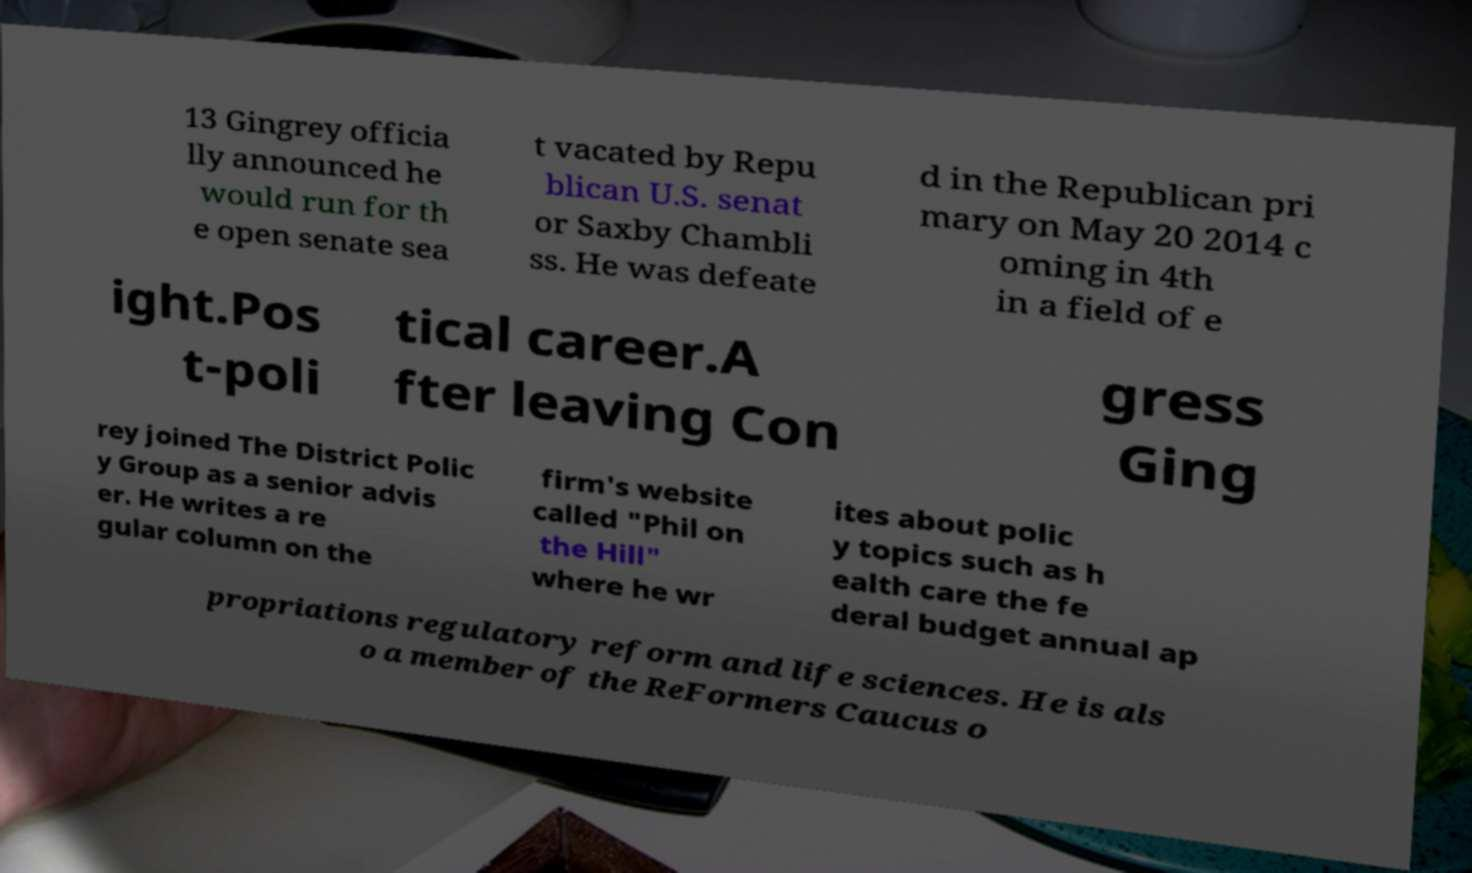What messages or text are displayed in this image? I need them in a readable, typed format. 13 Gingrey officia lly announced he would run for th e open senate sea t vacated by Repu blican U.S. senat or Saxby Chambli ss. He was defeate d in the Republican pri mary on May 20 2014 c oming in 4th in a field of e ight.Pos t-poli tical career.A fter leaving Con gress Ging rey joined The District Polic y Group as a senior advis er. He writes a re gular column on the firm's website called "Phil on the Hill" where he wr ites about polic y topics such as h ealth care the fe deral budget annual ap propriations regulatory reform and life sciences. He is als o a member of the ReFormers Caucus o 